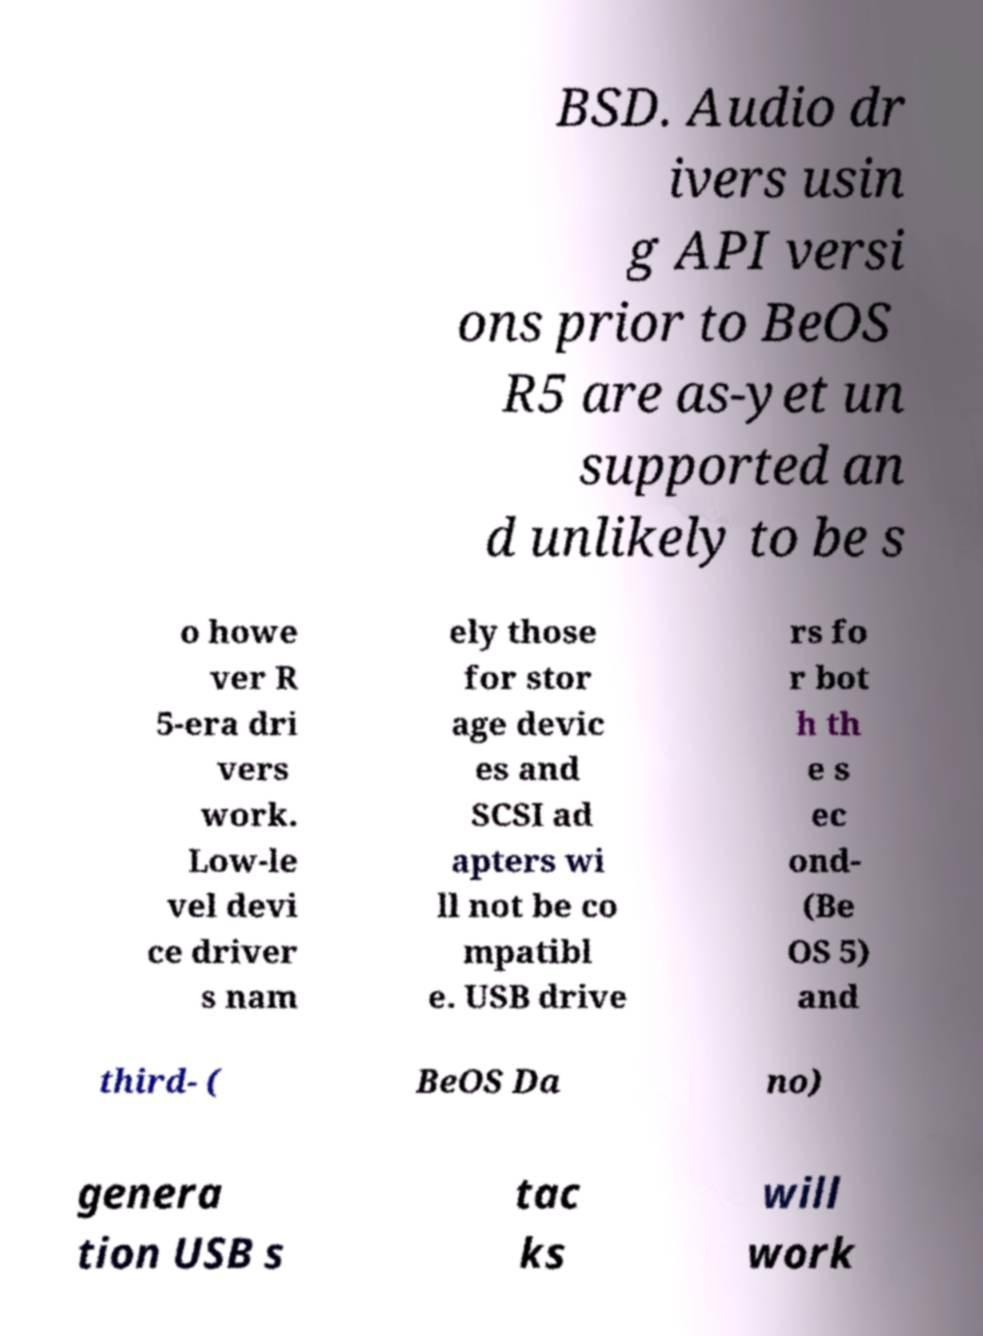Can you read and provide the text displayed in the image?This photo seems to have some interesting text. Can you extract and type it out for me? BSD. Audio dr ivers usin g API versi ons prior to BeOS R5 are as-yet un supported an d unlikely to be s o howe ver R 5-era dri vers work. Low-le vel devi ce driver s nam ely those for stor age devic es and SCSI ad apters wi ll not be co mpatibl e. USB drive rs fo r bot h th e s ec ond- (Be OS 5) and third- ( BeOS Da no) genera tion USB s tac ks will work 